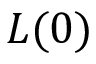<formula> <loc_0><loc_0><loc_500><loc_500>L ( 0 )</formula> 